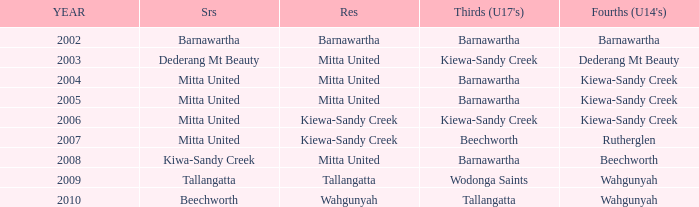Which Fourths (Under 14's) have Seniors of dederang mt beauty? Dederang Mt Beauty. 